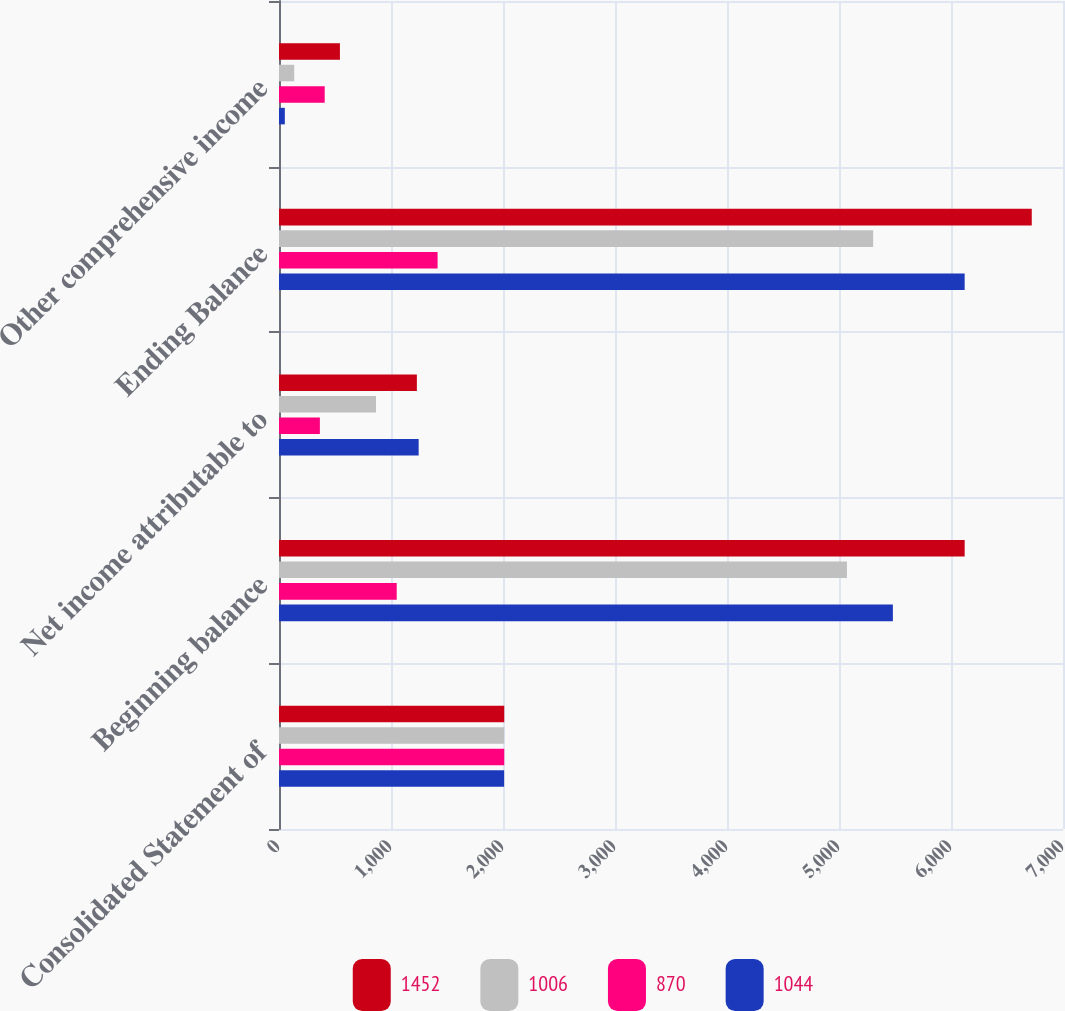Convert chart. <chart><loc_0><loc_0><loc_500><loc_500><stacked_bar_chart><ecel><fcel>Consolidated Statement of<fcel>Beginning balance<fcel>Net income attributable to<fcel>Ending Balance<fcel>Other comprehensive income<nl><fcel>1452<fcel>2011<fcel>6122<fcel>1231<fcel>6721<fcel>544<nl><fcel>1006<fcel>2011<fcel>5071<fcel>866<fcel>5305<fcel>136<nl><fcel>870<fcel>2011<fcel>1051<fcel>365<fcel>1416<fcel>408<nl><fcel>1044<fcel>2010<fcel>5481<fcel>1247<fcel>6122<fcel>52<nl></chart> 